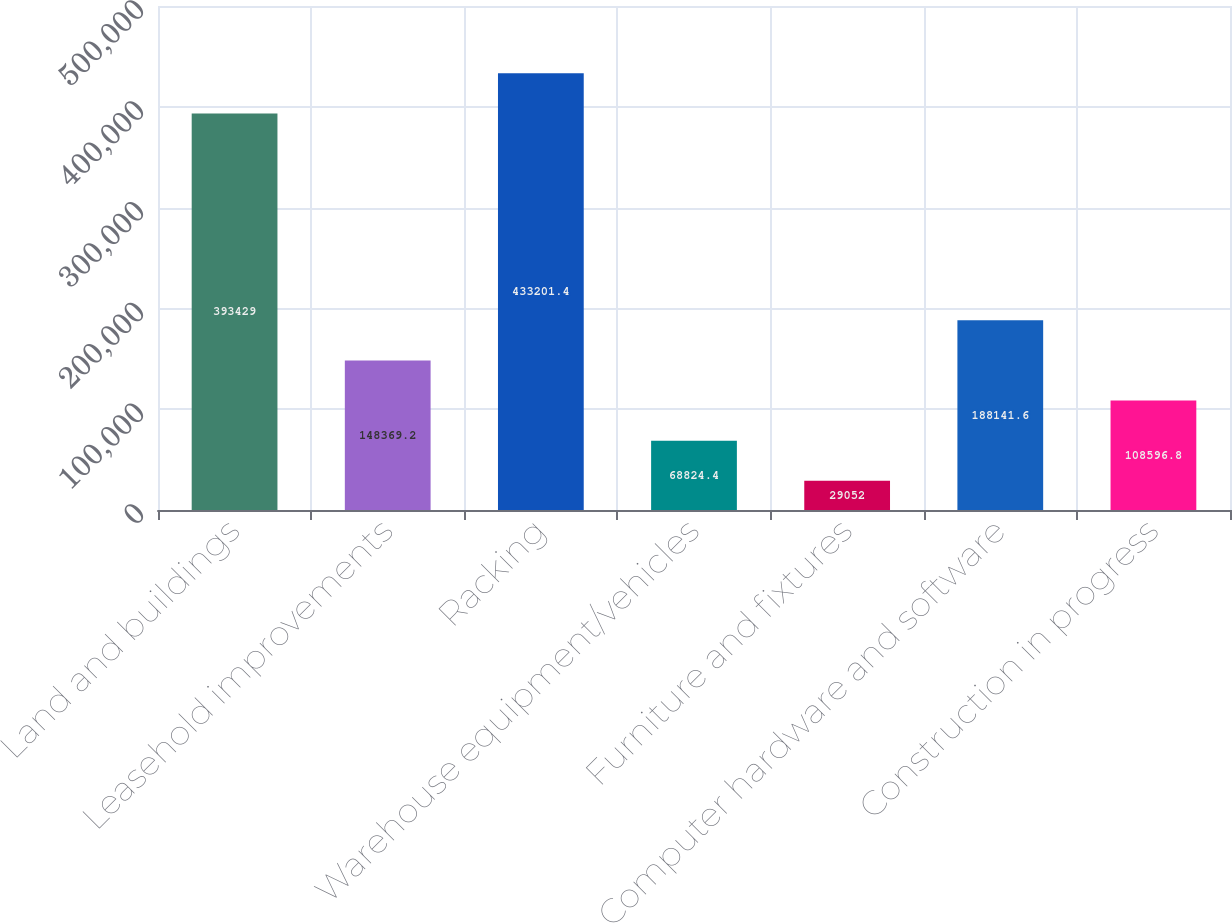<chart> <loc_0><loc_0><loc_500><loc_500><bar_chart><fcel>Land and buildings<fcel>Leasehold improvements<fcel>Racking<fcel>Warehouse equipment/vehicles<fcel>Furniture and fixtures<fcel>Computer hardware and software<fcel>Construction in progress<nl><fcel>393429<fcel>148369<fcel>433201<fcel>68824.4<fcel>29052<fcel>188142<fcel>108597<nl></chart> 